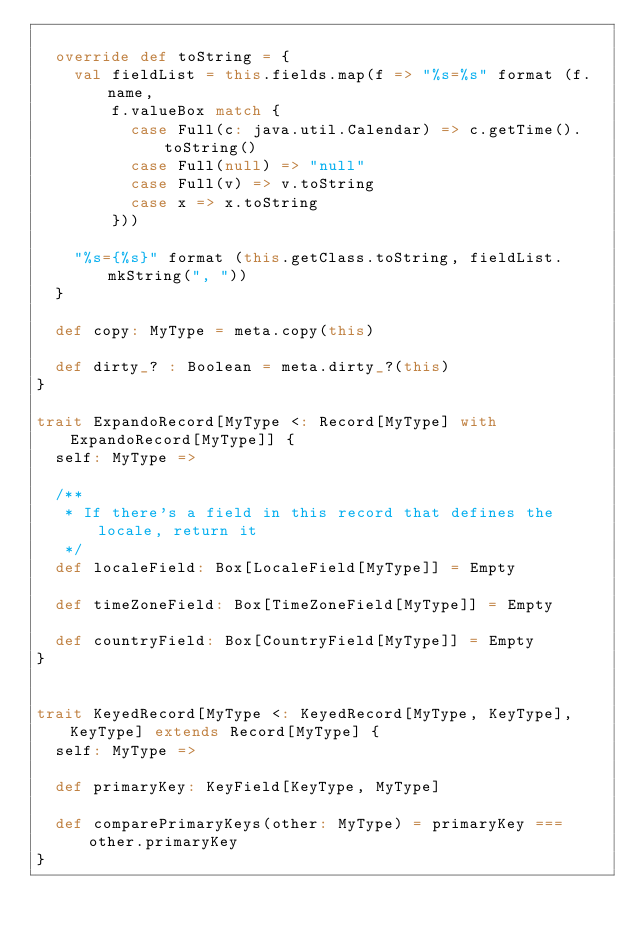Convert code to text. <code><loc_0><loc_0><loc_500><loc_500><_Scala_>
  override def toString = {
    val fieldList = this.fields.map(f => "%s=%s" format (f.name,
        f.valueBox match {
          case Full(c: java.util.Calendar) => c.getTime().toString()
          case Full(null) => "null"
          case Full(v) => v.toString
          case x => x.toString
        }))

    "%s={%s}" format (this.getClass.toString, fieldList.mkString(", "))
  }

  def copy: MyType = meta.copy(this)

  def dirty_? : Boolean = meta.dirty_?(this)
}

trait ExpandoRecord[MyType <: Record[MyType] with ExpandoRecord[MyType]] {
  self: MyType =>

  /**
   * If there's a field in this record that defines the locale, return it
   */
  def localeField: Box[LocaleField[MyType]] = Empty

  def timeZoneField: Box[TimeZoneField[MyType]] = Empty

  def countryField: Box[CountryField[MyType]] = Empty
}


trait KeyedRecord[MyType <: KeyedRecord[MyType, KeyType], KeyType] extends Record[MyType] {
  self: MyType =>

  def primaryKey: KeyField[KeyType, MyType]

  def comparePrimaryKeys(other: MyType) = primaryKey === other.primaryKey
}

</code> 